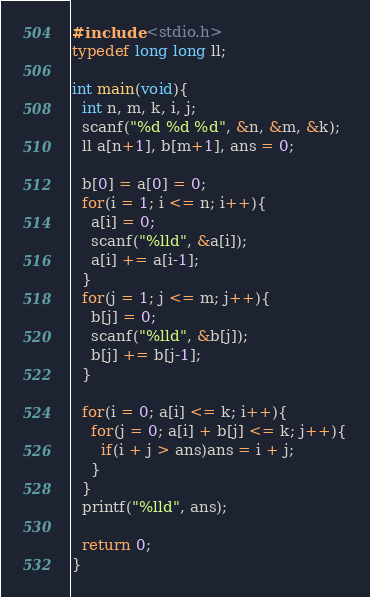<code> <loc_0><loc_0><loc_500><loc_500><_C_>#include <stdio.h>
typedef long long ll;

int main(void){
  int n, m, k, i, j;
  scanf("%d %d %d", &n, &m, &k);
  ll a[n+1], b[m+1], ans = 0;
  
  b[0] = a[0] = 0;
  for(i = 1; i <= n; i++){
    a[i] = 0;
    scanf("%lld", &a[i]);
    a[i] += a[i-1];
  }
  for(j = 1; j <= m; j++){
    b[j] = 0;
    scanf("%lld", &b[j]);
    b[j] += b[j-1];
  }
  
  for(i = 0; a[i] <= k; i++){
    for(j = 0; a[i] + b[j] <= k; j++){
      if(i + j > ans)ans = i + j;
    }
  }
  printf("%lld", ans);
  
  return 0;
}</code> 